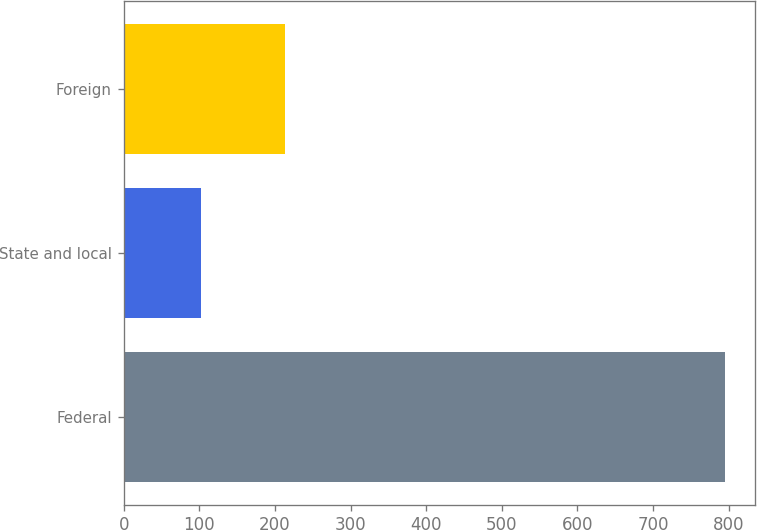<chart> <loc_0><loc_0><loc_500><loc_500><bar_chart><fcel>Federal<fcel>State and local<fcel>Foreign<nl><fcel>795<fcel>102<fcel>214<nl></chart> 